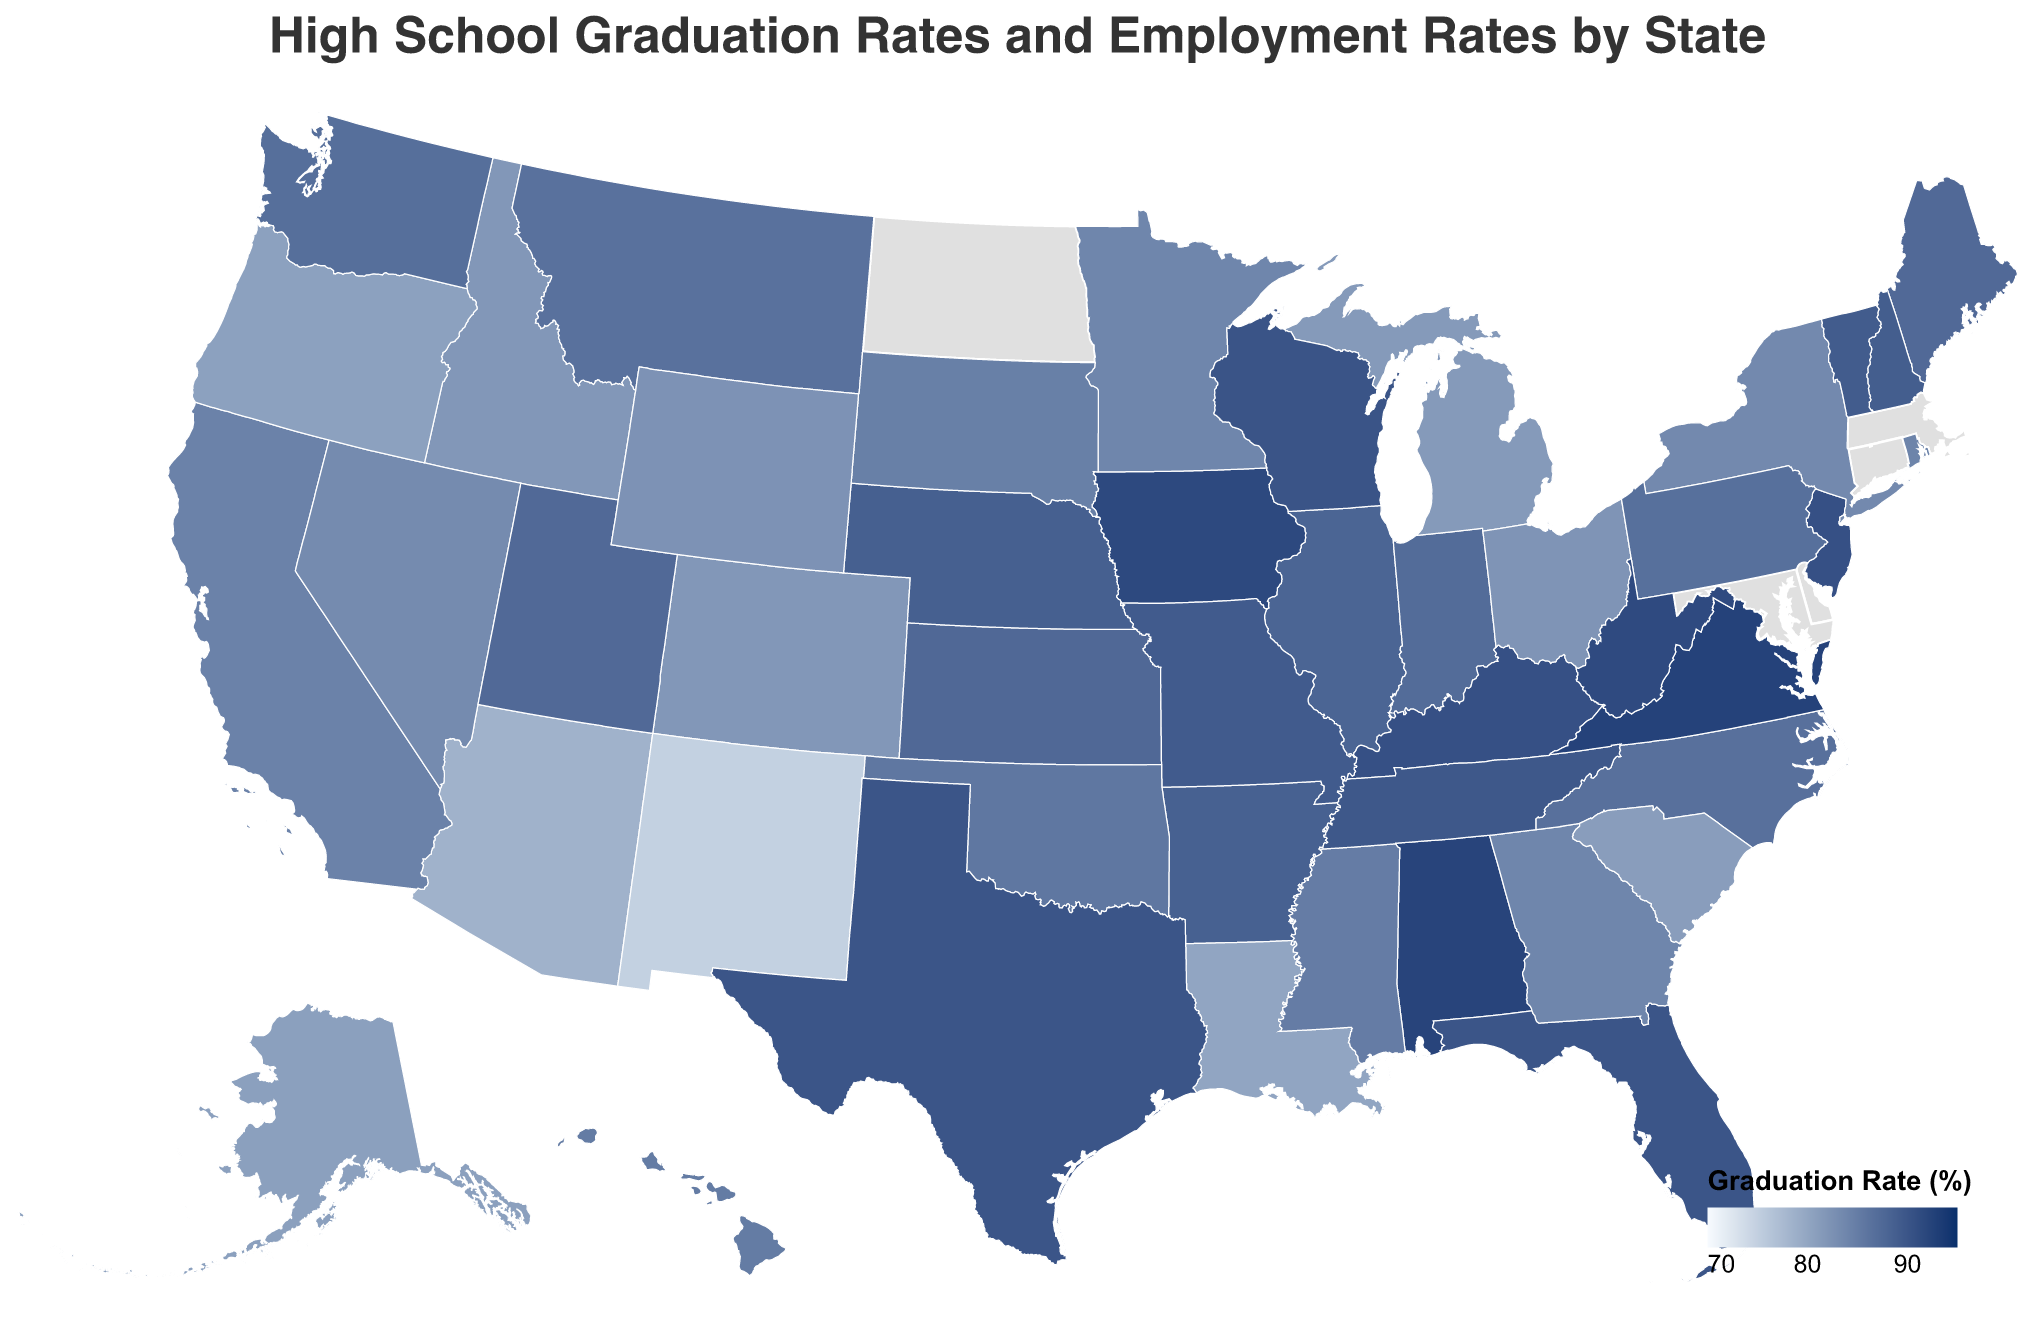What is the title of the figure? The title of the map is displayed at the top of the figure in large font.
Answer: High School Graduation Rates and Employment Rates by State Which state has the highest graduation rate? By examining the color legend and the shades on the map, the darkest shade indicating the highest rate can be identified. Virginia has the darkest shade indicating the highest graduation rate of 92.5%.
Answer: Virginia What is the top industry in Texas? Hover over Texas on the map, and the tooltip will display information about the state, including the top industry.
Answer: Energy Which states have a graduation rate greater than 90%? Identify states colored in the darkest shades, then use the tooltip to verify that the graduation rate is above 90%. The states are Alabama, Florida, Kentucky, Texas, Virginia, and West Virginia.
Answer: Alabama, Florida, Kentucky, Texas, Virginia, West Virginia How does the employment rate of Utah compare to that of West Virginia? Look at the shades of Utah and West Virginia and refer to the tooltip for their exact employment rates. Utah has an employment rate of 97.5%, while West Virginia has 94.6%.
Answer: Utah has a higher employment rate than West Virginia Which state has the lowest graduation rate and what is its employment rate? Check the lightest shades on the map and verify with the tooltip. New Mexico has the lowest graduation rate of 74.9% and an employment rate of 95.2%.
Answer: New Mexico, 95.2% Calculate the average graduation rate of the states whose top industry is Agriculture. Identify the states with Agriculture as their top industry, check their graduation rates, and calculate the average: (88.5 + 81.7 + 91.6 + 88.6 + 85.0 + 82.3) / 6 = 86.13.
Answer: 86.1 Which states have both graduation and employment rates above 97%? Scan the map for the darkest shades and use the tooltips to confirm the rates: New Hampshire, Hawaii, and Utah meet both criteria.
Answer: New Hampshire, Hawaii, Utah Is there a clear correlation between high school graduation rates and local employment rates in the figure? Compare the colors representing high school graduation rates with the tooltip information on employment rates. There is no clear visual correlation; while some states with high graduation rates also have high employment rates, this is not universal.
Answer: No clear correlation Which state has the top industry in Finance, and what are its graduation and employment rates? Hover over the state of Illinois to display the relevant information with tooltip details. Illinois has Finance as its top industry, with a graduation rate of 88.0% and an employment rate of 96.1%.
Answer: Illinois, 88.0%, 96.1% 